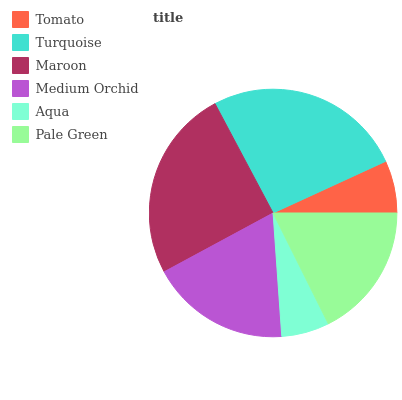Is Aqua the minimum?
Answer yes or no. Yes. Is Turquoise the maximum?
Answer yes or no. Yes. Is Maroon the minimum?
Answer yes or no. No. Is Maroon the maximum?
Answer yes or no. No. Is Turquoise greater than Maroon?
Answer yes or no. Yes. Is Maroon less than Turquoise?
Answer yes or no. Yes. Is Maroon greater than Turquoise?
Answer yes or no. No. Is Turquoise less than Maroon?
Answer yes or no. No. Is Medium Orchid the high median?
Answer yes or no. Yes. Is Pale Green the low median?
Answer yes or no. Yes. Is Pale Green the high median?
Answer yes or no. No. Is Maroon the low median?
Answer yes or no. No. 